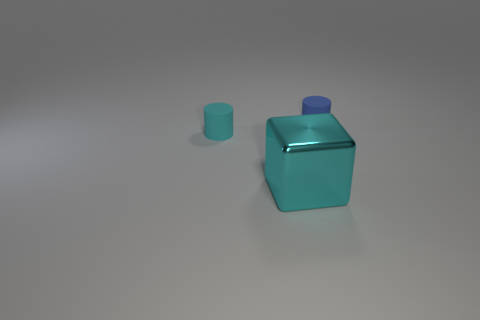Add 3 blue rubber cylinders. How many objects exist? 6 Subtract all cubes. How many objects are left? 2 Add 2 large cyan objects. How many large cyan objects exist? 3 Subtract 0 purple cylinders. How many objects are left? 3 Subtract all small cyan cylinders. Subtract all small cyan rubber things. How many objects are left? 1 Add 3 cyan objects. How many cyan objects are left? 5 